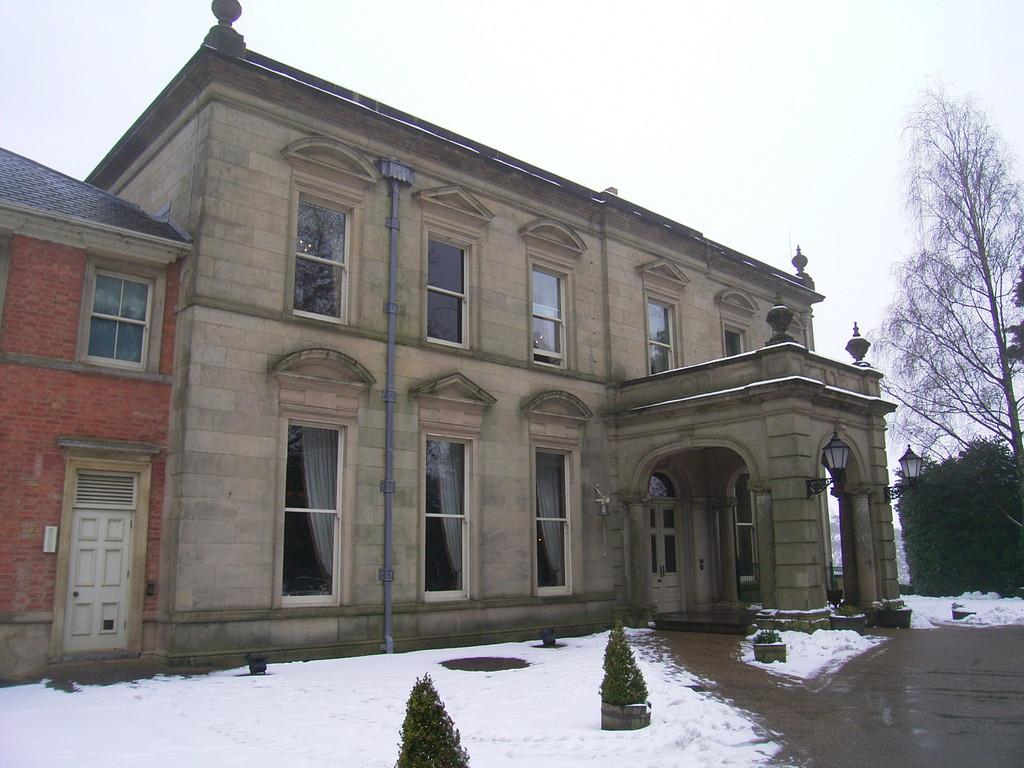What type of structure is present in the image? There is a building in the image. What feature of the building is mentioned in the facts? The building has many windows. What weather condition can be observed in the image? There is snow visible in the image. What type of vegetation is present near the building? There are plants in front of the building. What part of the natural environment is visible in the image? The sky is visible above the building. What type of plantation is visible in the image? There is no plantation present in the image; it features a building with snow, plants, and a visible sky. Can you see a stamp on any of the windows in the image? There is no mention of a stamp on any of the windows in the image. 